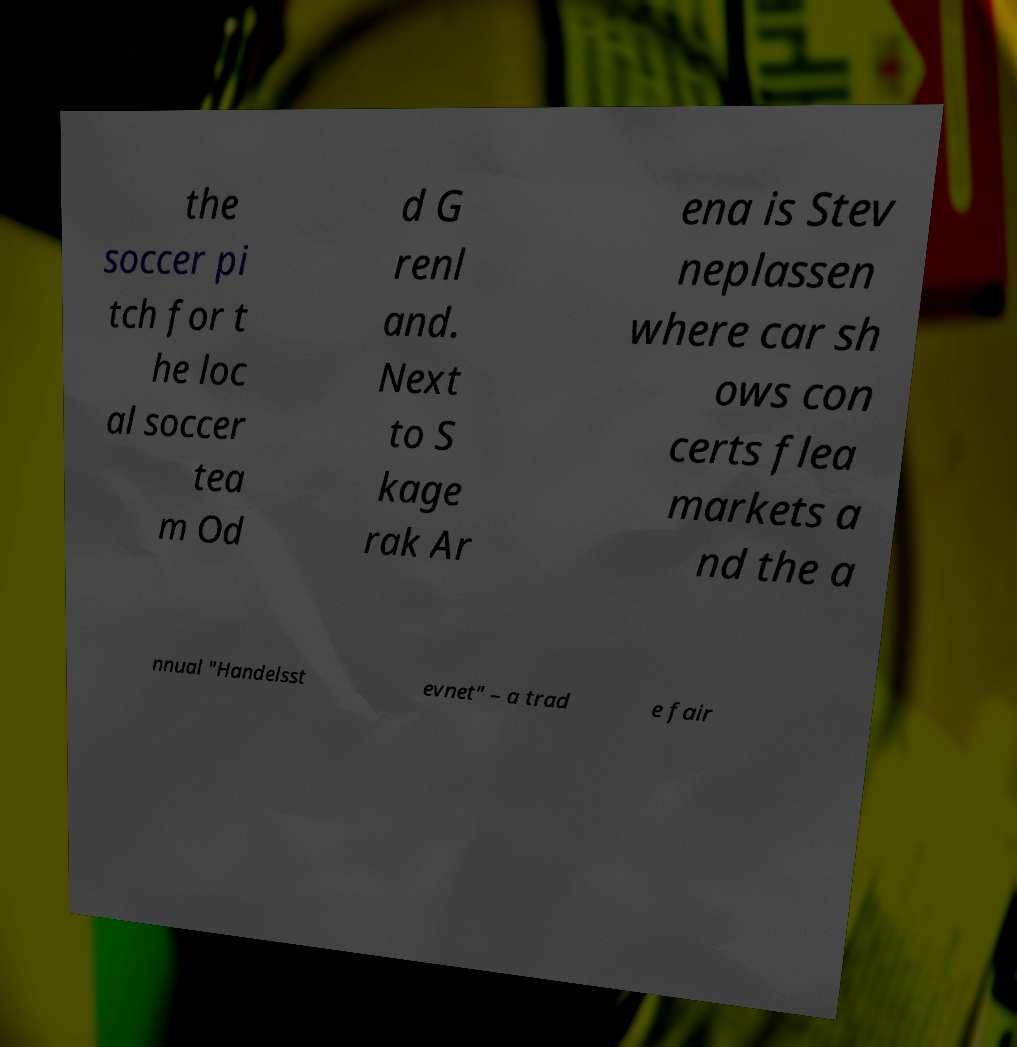There's text embedded in this image that I need extracted. Can you transcribe it verbatim? the soccer pi tch for t he loc al soccer tea m Od d G renl and. Next to S kage rak Ar ena is Stev neplassen where car sh ows con certs flea markets a nd the a nnual "Handelsst evnet" – a trad e fair 